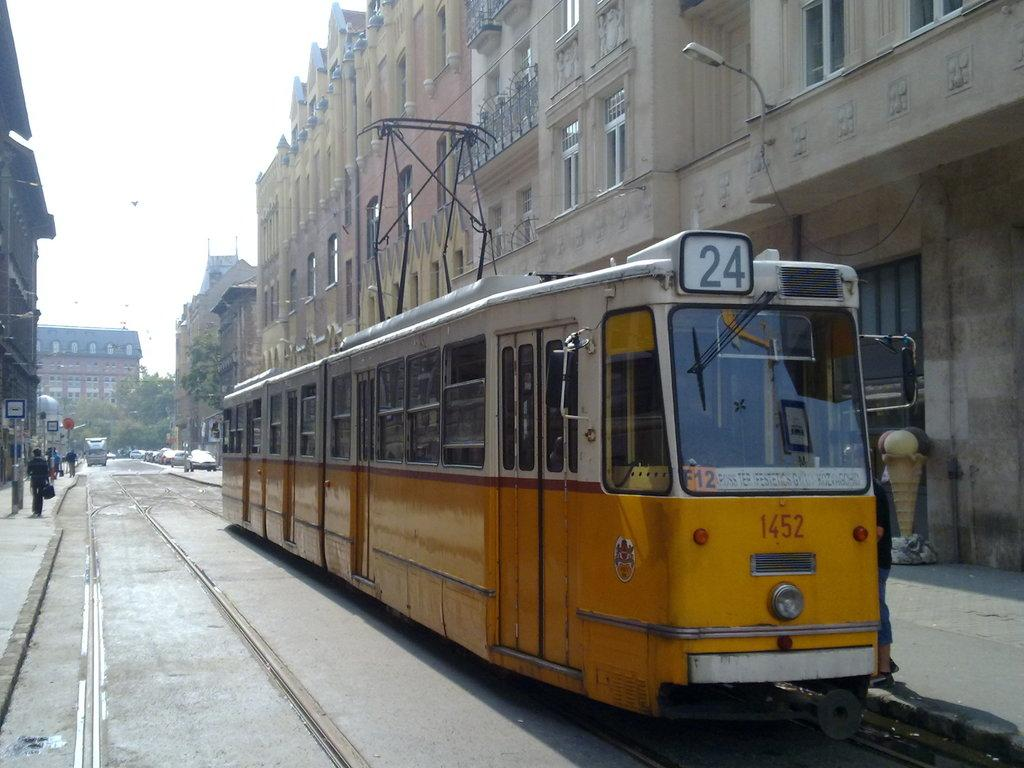Provide a one-sentence caption for the provided image. A yellow streetcar with the #24 on the roof and #1452 lower down is seen on a city street. 